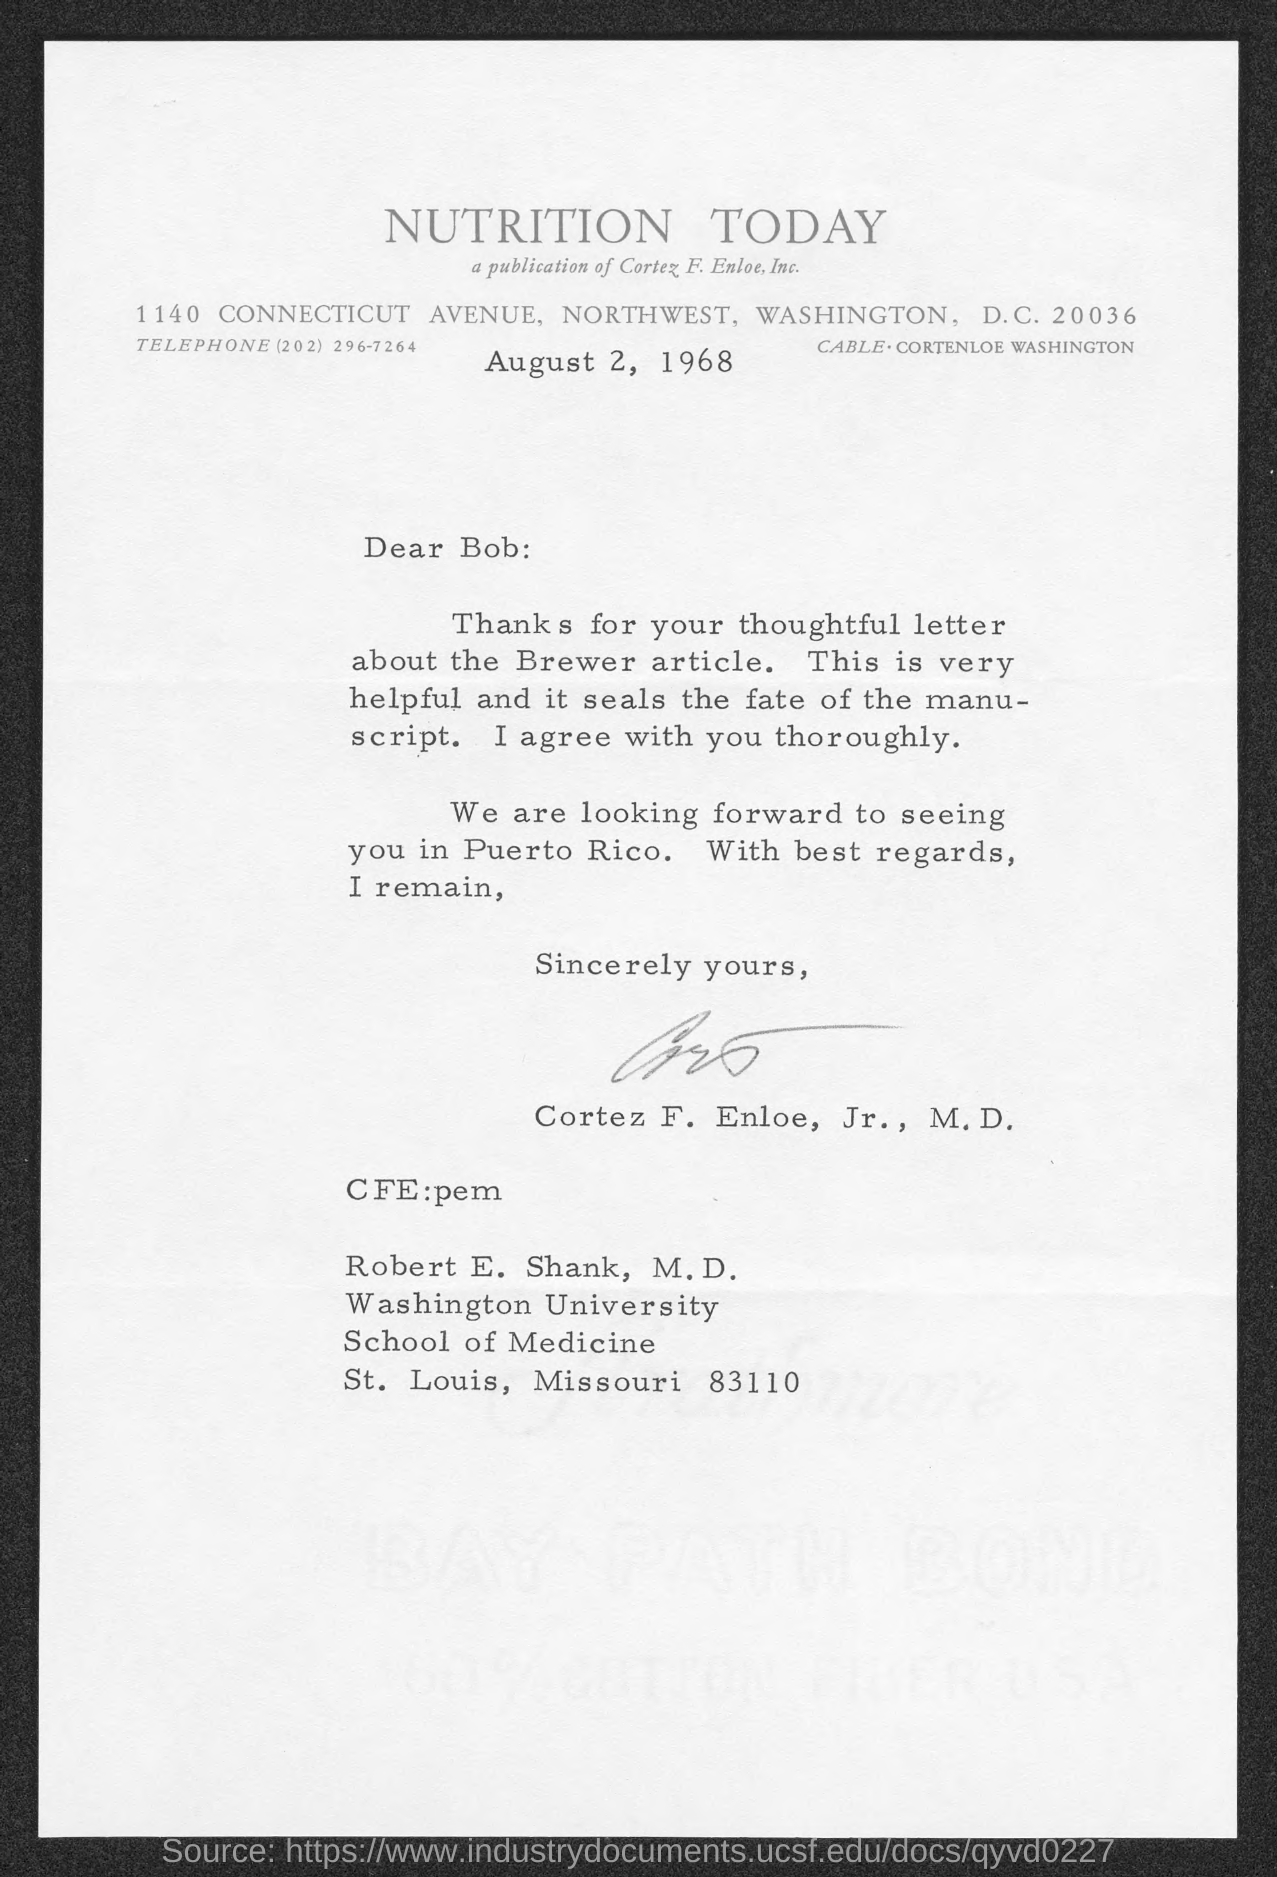Indicate a few pertinent items in this graphic. The thoughtful letter was about the Brewer article. To whom is this letter addressed?" is a question asking for information about the recipient of the letter. The letter is from Cortez F. Enloe, Jr. The date on the document is August 2, 1968. 